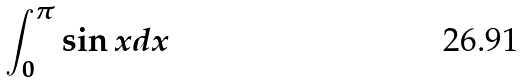Convert formula to latex. <formula><loc_0><loc_0><loc_500><loc_500>\int _ { 0 } ^ { \pi } \sin x d x</formula> 